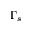Convert formula to latex. <formula><loc_0><loc_0><loc_500><loc_500>\Gamma _ { s }</formula> 